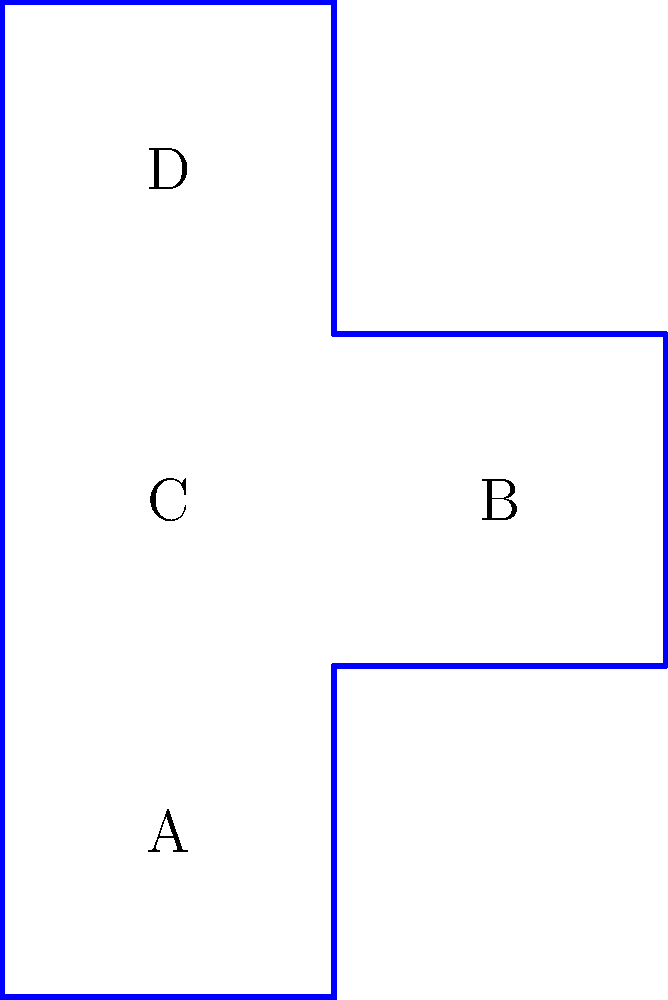As a manager focused on efficient project execution, you need to quickly visualize the final product based on a 2D pattern. Given the unfolded pattern on the left, which face will be opposite to face A when the cube is folded? To determine the opposite face of A in the folded cube, let's follow a step-by-step approach:

1. Analyze the unfolded pattern:
   - Face A is at the bottom left
   - Faces B, C, and D are connected to A

2. Visualize the folding process:
   - Face A will form the bottom of the cube
   - Face B will fold up to form the front
   - Face C will fold up to form the left side
   - Face D will fold up to form the back

3. Identify the missing faces:
   - The right side of the cube is not visible in the pattern
   - The top of the cube is not visible in the pattern

4. Deduce the opposite face:
   - Since A is at the bottom, its opposite face must be at the top
   - The top face is not visible in the unfolded pattern

5. Conclude:
   - The face opposite to A is the unmarked top face of the cube

This visualization process allows for quick and efficient problem-solving, aligning with the manager's focus on timely project completion.
Answer: The unmarked top face 